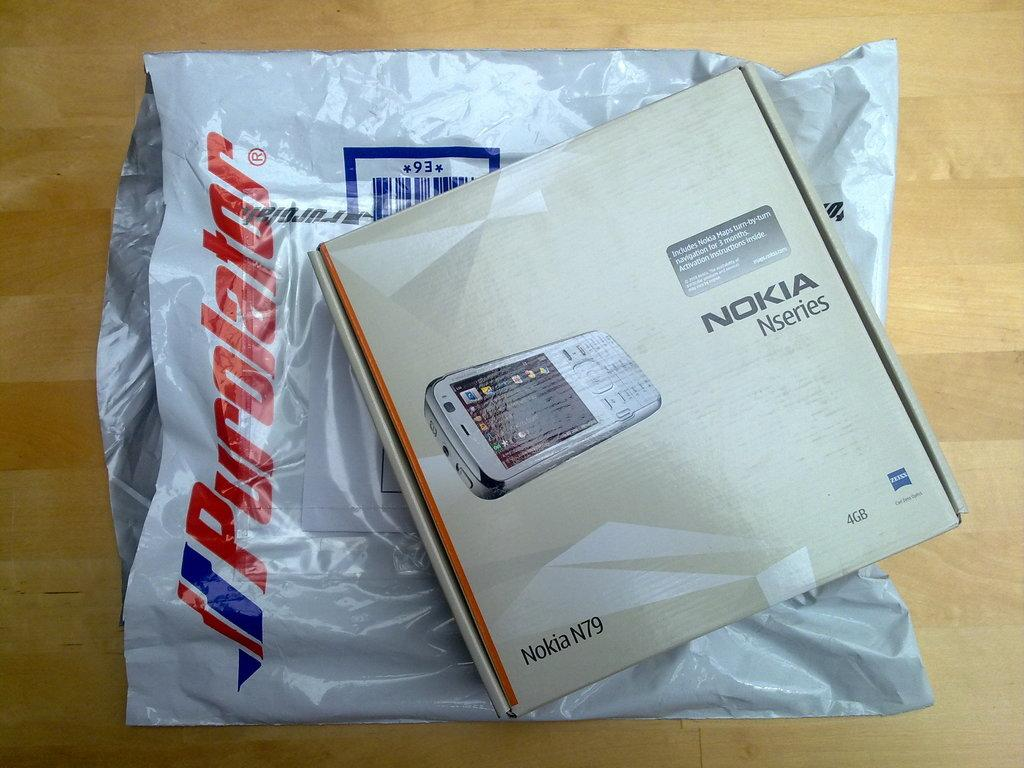What is inside the box that is visible in the image? There is a mobile in the box that is visible in the image. What is covering the bottom of the box? There is a cover at the bottom of the box. Where is the box and cover placed in the image? The box and cover are placed on a wooden table. What type of paper or sheet is used to express an opinion in the image? There is no paper, sheet, or opinion expressed in the image; it only shows a box with a mobile and a cover on a wooden table. 